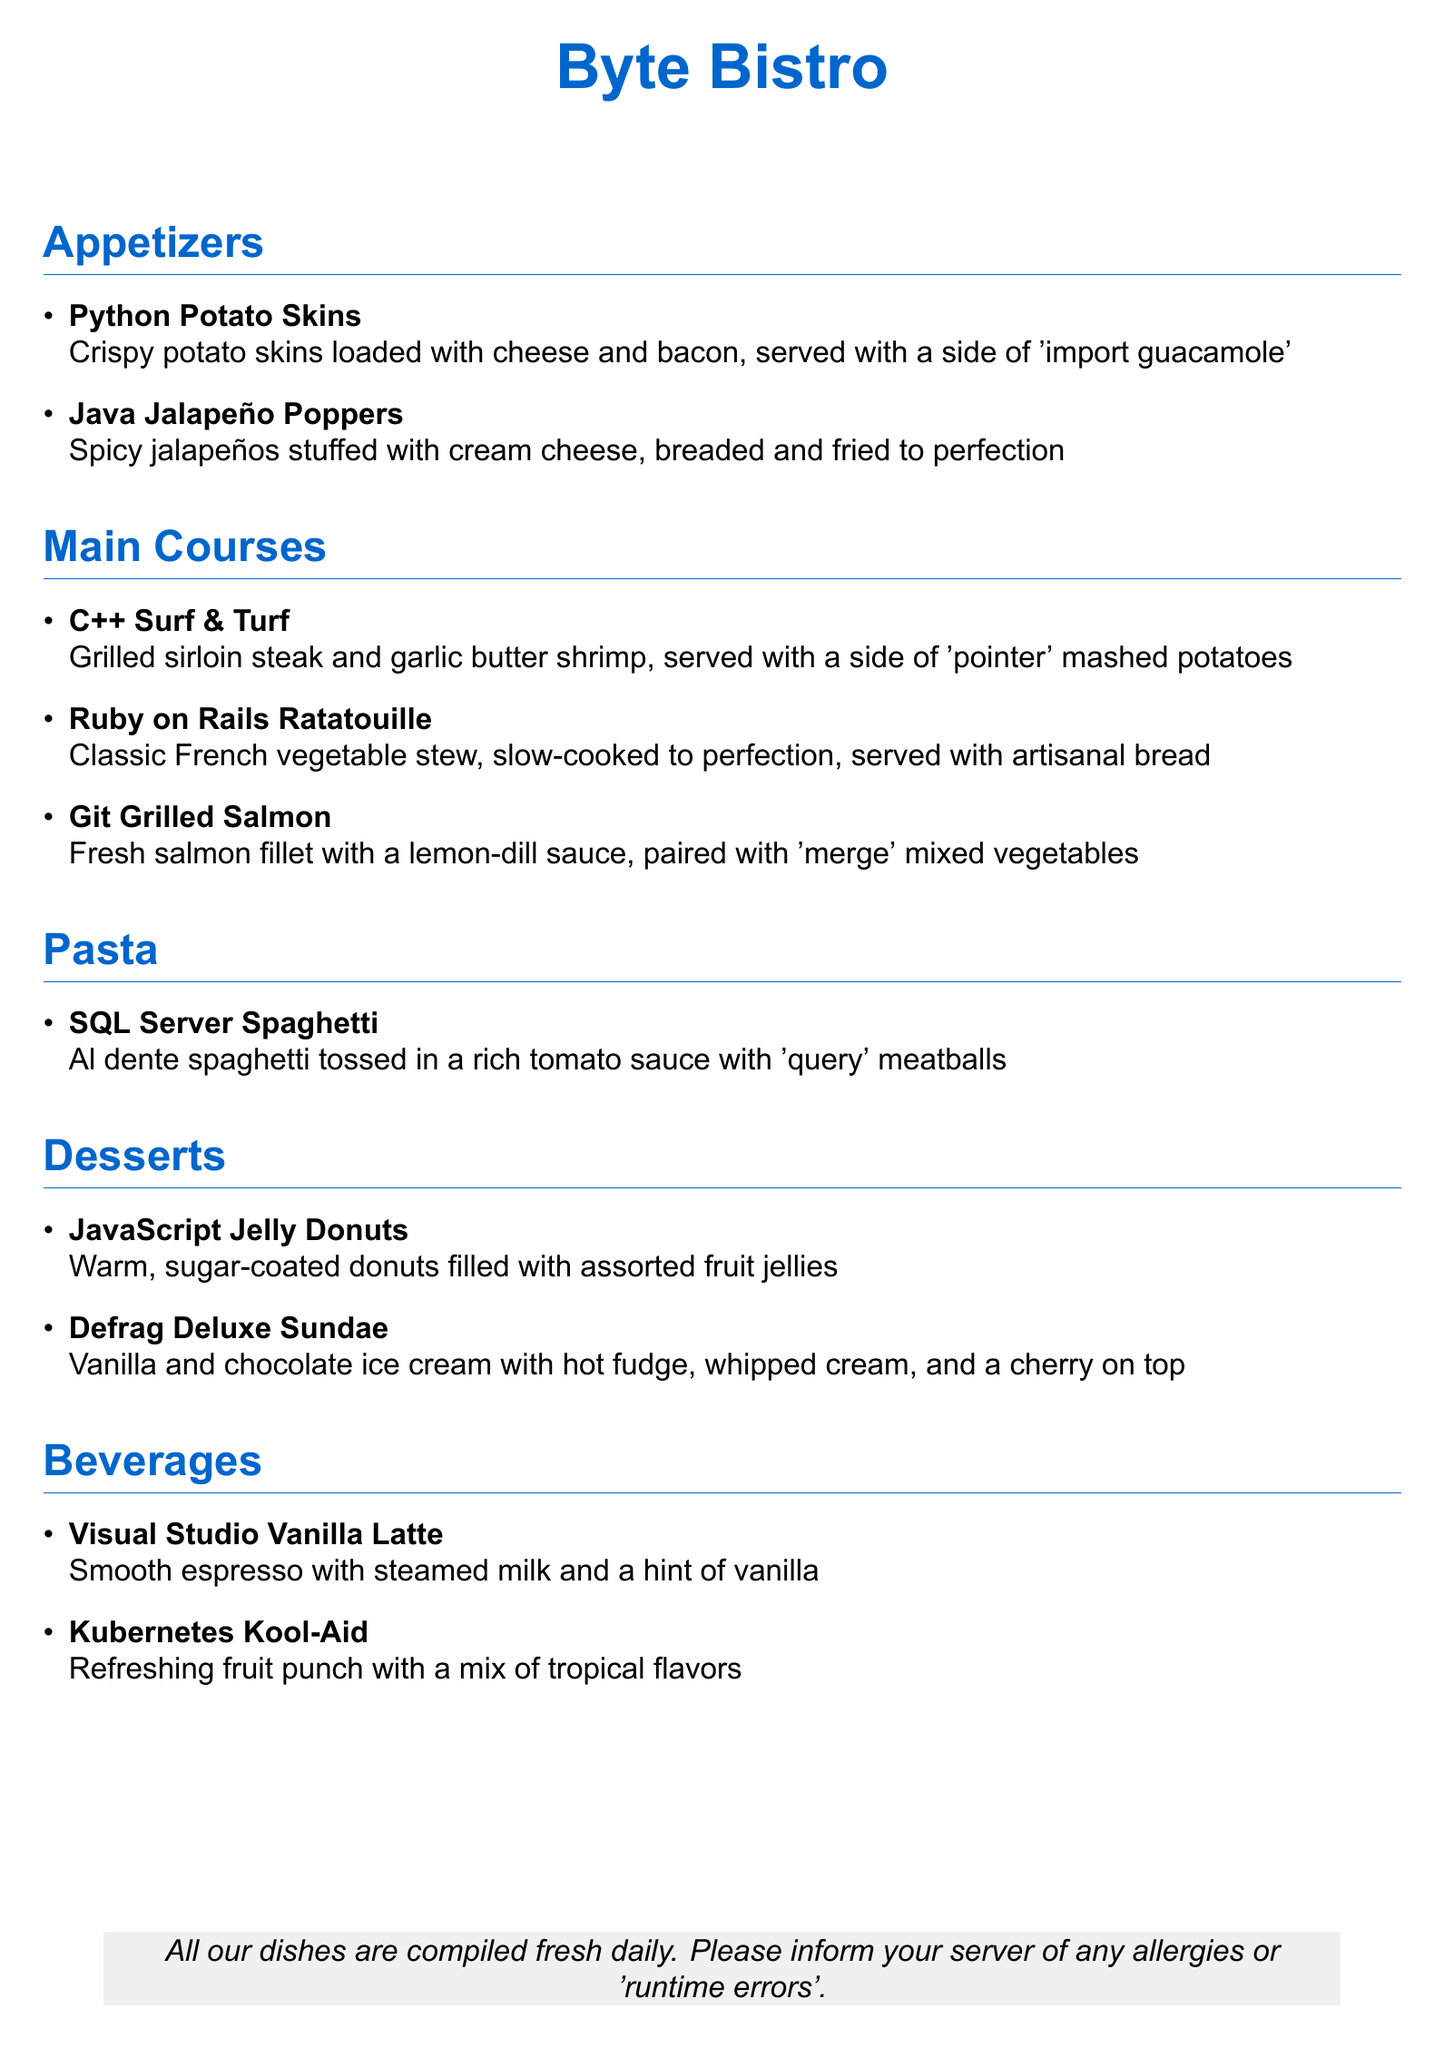What is the name of the restaurant? The name of the restaurant is presented at the top of the menu in a large font.
Answer: Byte Bistro What dish is served with a side of 'import guacamole'? The dish is found under the Appetizers section; it is crispy potato skins.
Answer: Python Potato Skins Which beverage has vanilla in it? The beverage section lists a drink that specifically mentions vanilla flavoring.
Answer: Visual Studio Vanilla Latte How many appetizers are listed in the menu? The number of appetizers can be counted in the Appetizers section of the menu.
Answer: 2 What is the main ingredient in the SQL Server Spaghetti? The main ingredient can be determined by the description in the Pasta section of the menu.
Answer: Spaghetti Which dessert features both vanilla and chocolate? The dessert section includes a specific item that has both flavors.
Answer: Defrag Deluxe Sundae What type of cuisine is represented by the Ruby on Rails Ratatouille? The description under the Main Courses section indicates the style of dish this is.
Answer: French What is the filling of the JavaScript Jelly Donuts? The menu specifies what the donuts are filled with in the description.
Answer: Assorted fruit jellies What is the total number of desserts offered? The number of desserts can be counted in the Desserts section of the menu.
Answer: 2 